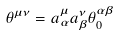Convert formula to latex. <formula><loc_0><loc_0><loc_500><loc_500>{ \theta } ^ { { \mu } { \nu } } = { a } ^ { \mu } _ { \alpha } { a } ^ { \nu } _ { \beta } { \theta } _ { 0 } ^ { { \alpha } { \beta } }</formula> 